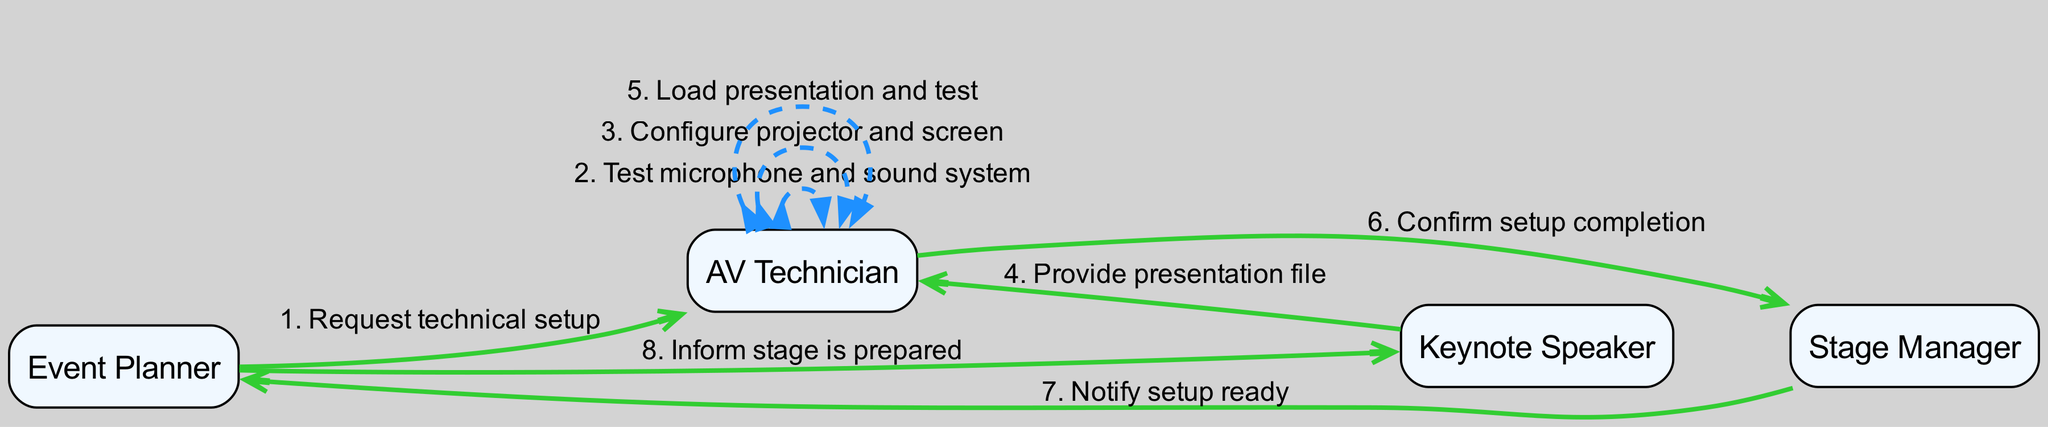What is the first message in the sequence? The diagram starts with the message "Request technical setup" from the Event Planner to the AV Technician, which is the first step in the sequence.
Answer: Request technical setup Which actor is responsible for loading the presentation file? The AV Technician is the actor who interacts with the Keynote Speaker to receive the presentation file, and then they load and test the presentation following that.
Answer: AV Technician How many total actors are involved in this sequence? By counting the distinct actors listed in the diagram—Event Planner, AV Technician, Keynote Speaker, and Stage Manager—we find that there are four actors.
Answer: 4 What does the AV Technician do after receiving the presentation file? After receiving the presentation file from the Keynote Speaker, the AV Technician's next action is to load the presentation and test it, signifying a direct response to the prior step.
Answer: Load presentation and test Which actor confirms the completion of the setup? The AV Technician is responsible for confirming that the technical setup is completed before any further notifications or actions occur in the sequence.
Answer: AV Technician What is the final message sent in the sequence? The sequence concludes with the Event Planner informing the Keynote Speaker that the stage is prepared, marking the final interaction in the process.
Answer: Inform stage is prepared What type of message does the AV Technician send to themselves when testing the sound system? The AV Technician sends a self-message, which is defined as a loopback edge in sequence diagrams. This indicates an internal process of testing that does not involve another actor.
Answer: Test microphone and sound system Who does the Stage Manager notify after confirming the setup is complete? After the AV Technician confirms the setup is complete, the Stage Manager is responsible for notifying the Event Planner, showing a chain of confirmation and updates in the setup process.
Answer: Event Planner 